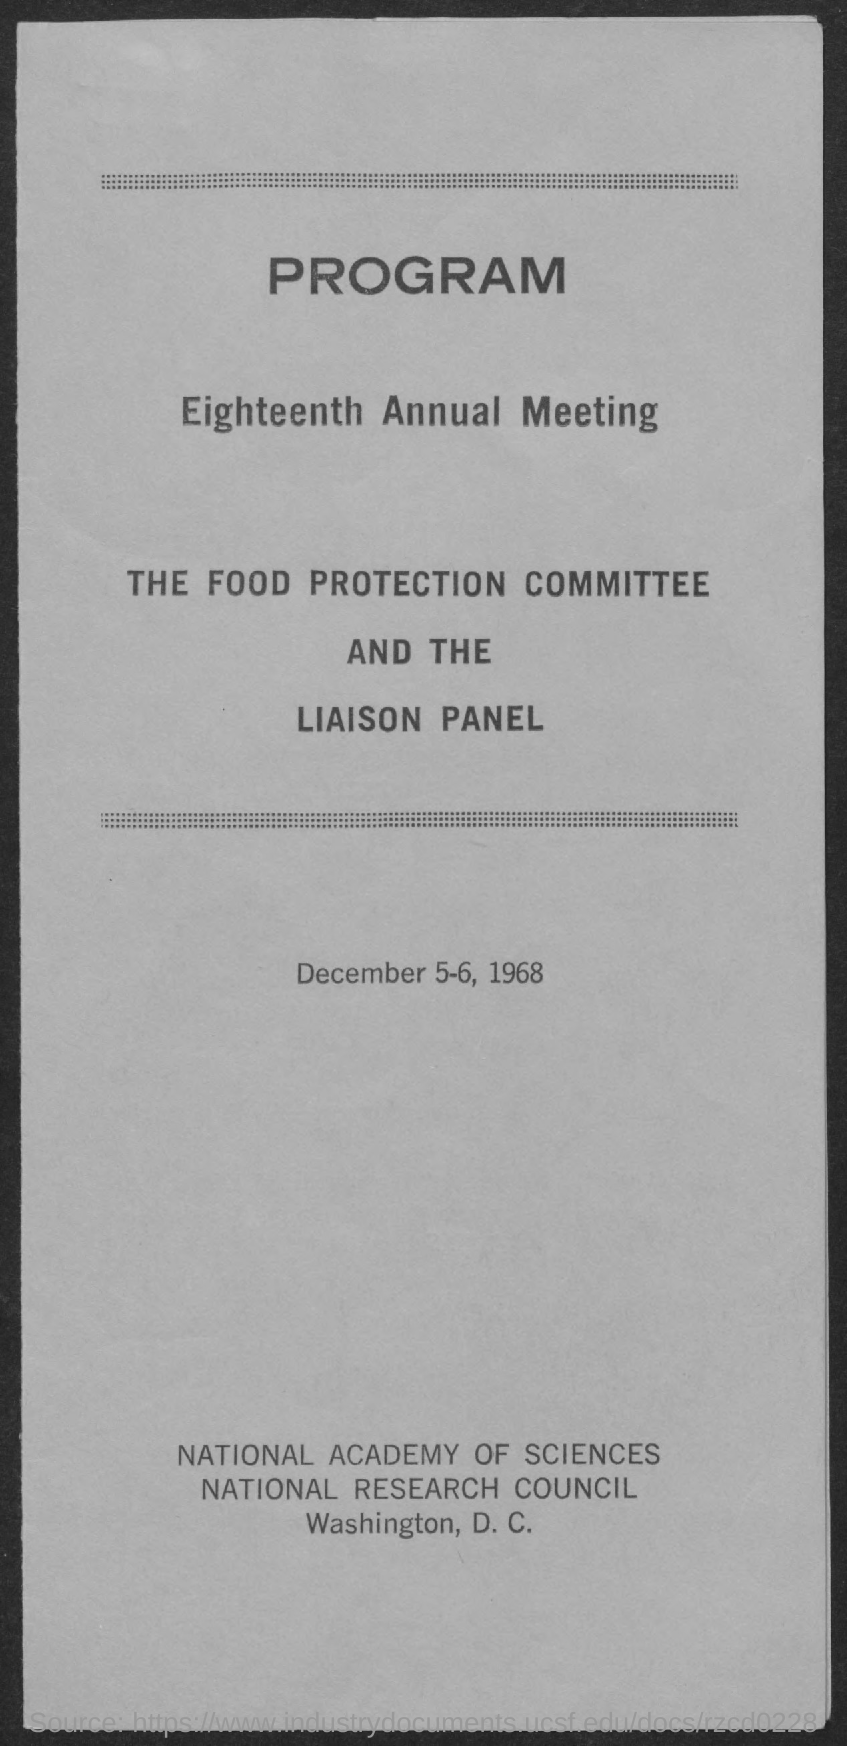What is the first title in the document?
Offer a terse response. Program. What is the second title in this document?
Provide a short and direct response. Eighteenth Annual Meeting. What are the dates of the meeting?
Provide a short and direct response. December 5-6, 1968. 